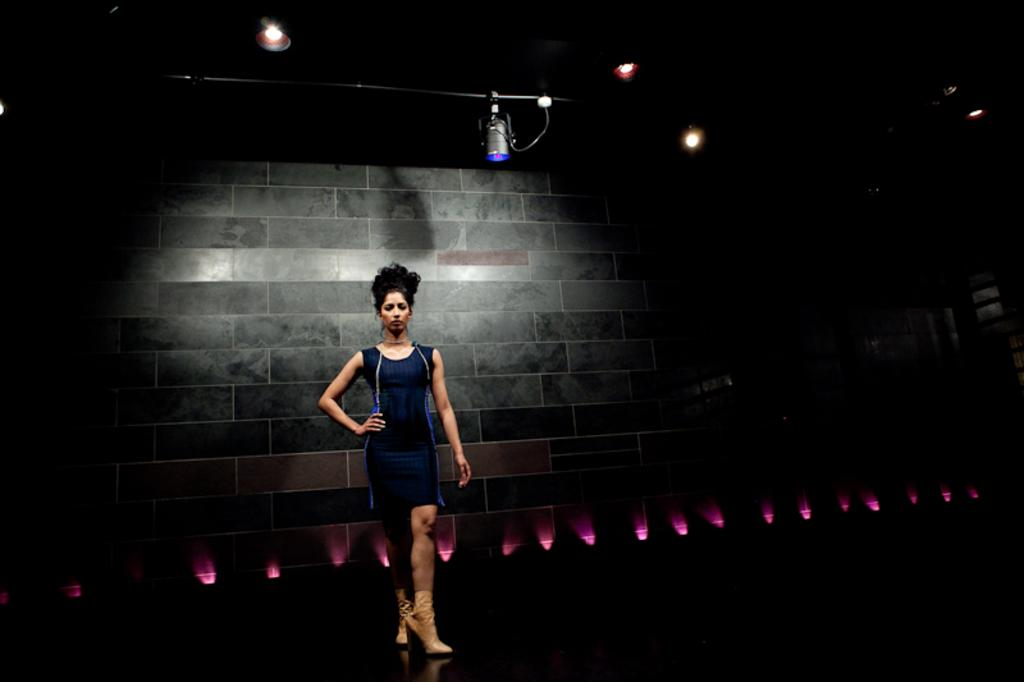What is the main subject of the image? The main subject of the image is a woman standing. What is the woman standing on? The woman is standing on the floor. What can be seen in the background of the image? There are lights and a wall visible in the background of the image. What type of prose is the woman reciting in the image? There is no indication in the image that the woman is reciting any prose. How does the woman provide support to the wall in the image? The woman is not providing support to the wall in the image; she is simply standing near it. 